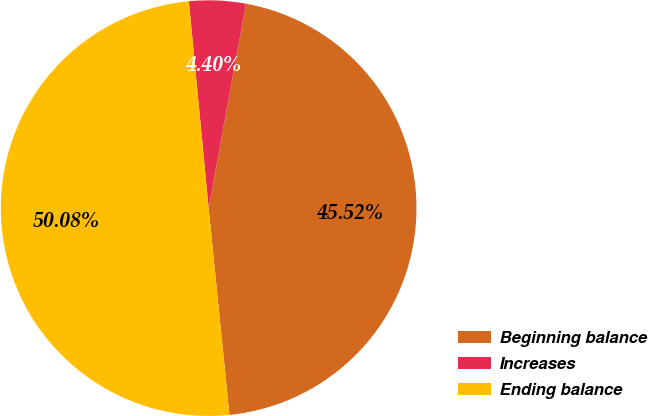Convert chart to OTSL. <chart><loc_0><loc_0><loc_500><loc_500><pie_chart><fcel>Beginning balance<fcel>Increases<fcel>Ending balance<nl><fcel>45.52%<fcel>4.4%<fcel>50.08%<nl></chart> 